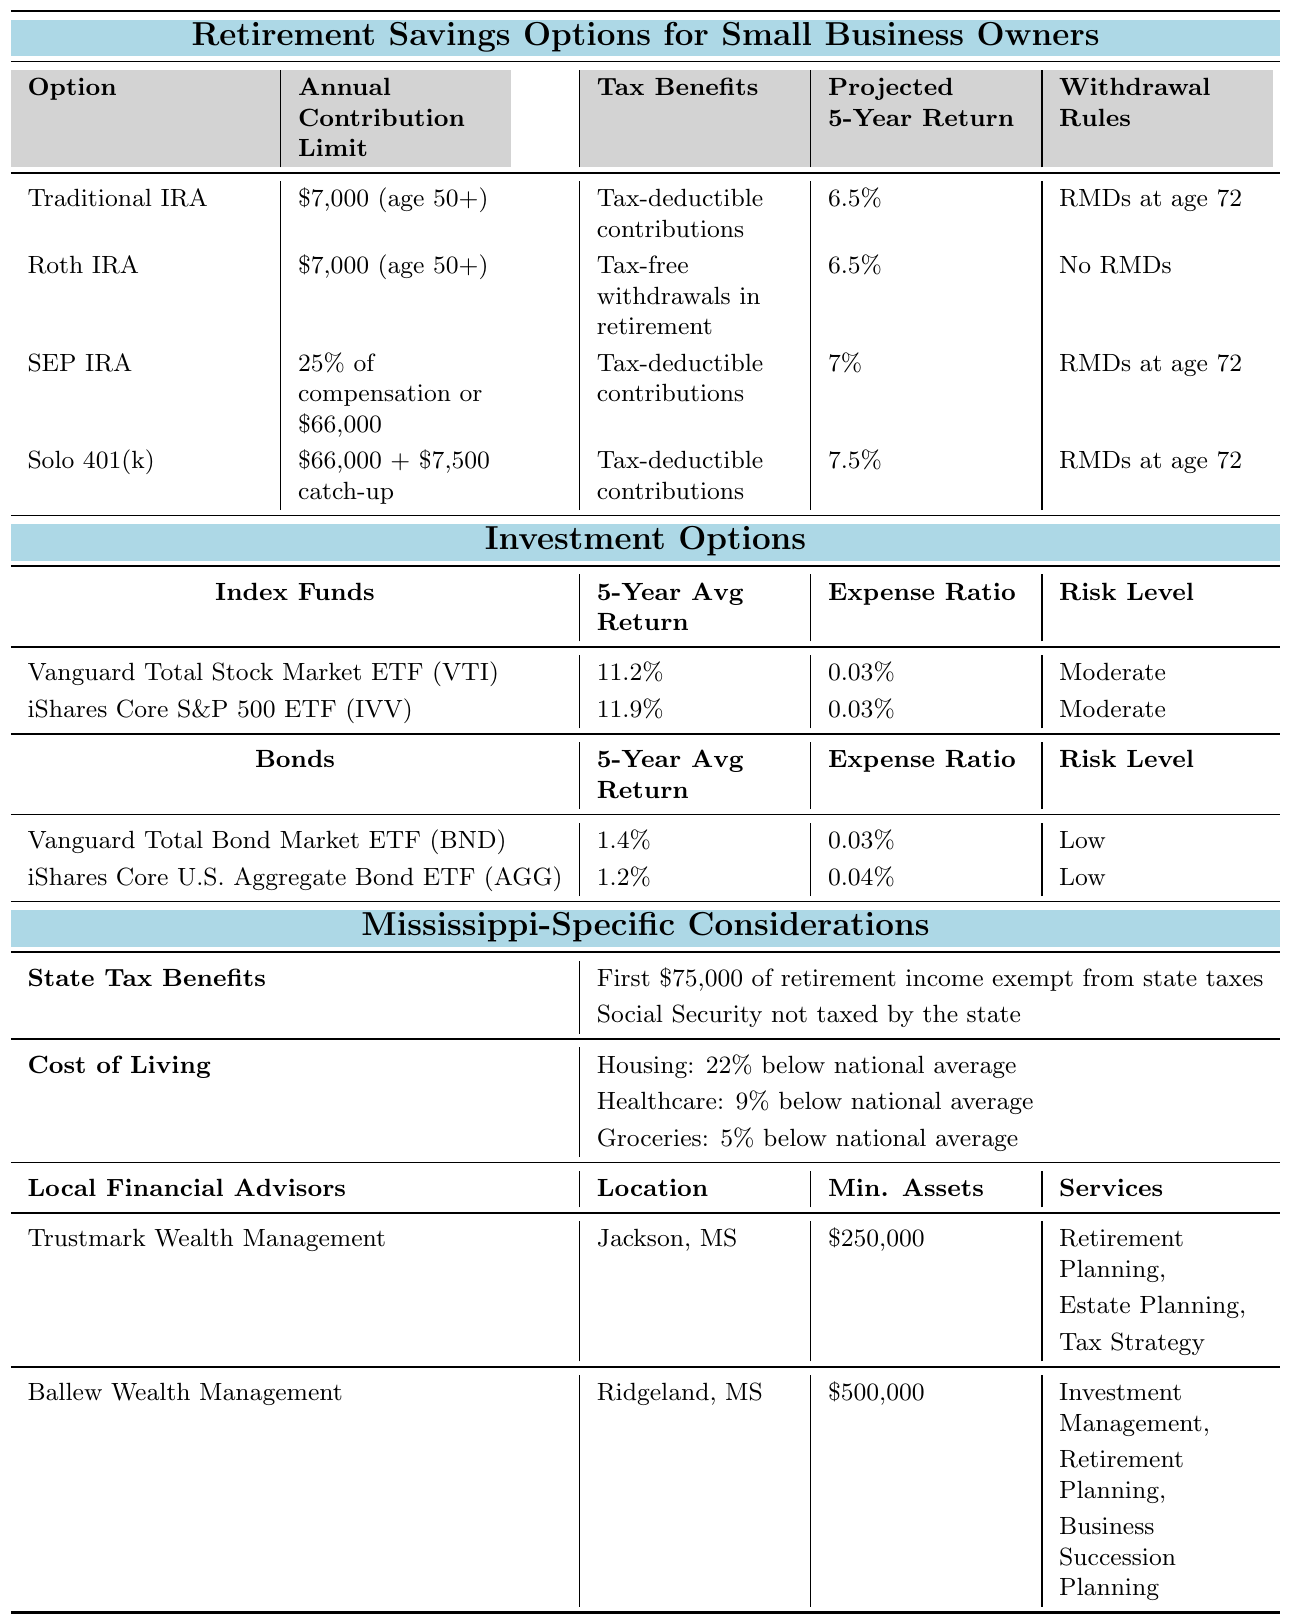What is the annual contribution limit for a Roth IRA? The table states that the annual contribution limit for a Roth IRA is $7,000 for individuals aged 50 and over.
Answer: $7,000 What is the projected 5-year return for a Solo 401(k)? According to the table, the projected 5-year return for a Solo 401(k) is 7.5%.
Answer: 7.5% Is Social Security taxed by the state of Mississippi? The table indicates that Social Security is not taxed by the state of Mississippi.
Answer: No Which retirement savings option has the highest projected return? The table shows that the Solo 401(k) has the highest projected 5-year return at 7.5%.
Answer: Solo 401(k) What is the difference in annual contribution limits between a Traditional IRA and a SEP IRA? The Traditional IRA has a contribution limit of $7,000, while the SEP IRA allows 25% of compensation or up to $66,000. The difference depends on the contributor's compensation, but if we consider the maximum for SEP at $66,000, the difference is $66,000 - $7,000 = $59,000.
Answer: $59,000 (if using max SEP limit) What is the risk level of the Vanguard Total Stock Market ETF (VTI)? The table specifies that the risk level of the Vanguard Total Stock Market ETF (VTI) is moderate.
Answer: Moderate If I contribute the maximum to a SEP IRA, what would my total contribution be if I fully utilize the limit? The maximum contribution to a SEP IRA is $66,000. Thus, if contributing the maximum, the total contribution would simply be $66,000.
Answer: $66,000 How do the projected returns of the bond investments compare to those of the index funds? The projected returns for the bond investments (1.2% to 1.4%) are significantly lower than those for the index funds (11.2% to 11.9%).
Answer: Index funds have higher returns Which local financial advisor requires the least minimum assets? According to the table, Trustmark Wealth Management requires a minimum of $250,000, which is less than Ballew Wealth Management's requirement of $500,000.
Answer: Trustmark Wealth Management What are the cost-of-living factors specific to Mississippi mentioned in the table? The table mentions that housing is 22% below the national average, healthcare is 9% below the national average, and groceries are 5% below the national average.
Answer: Housing, healthcare, groceries are lower than average 